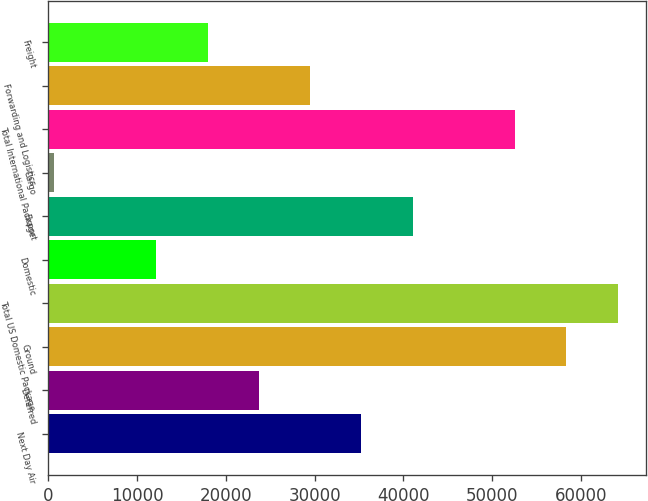Convert chart to OTSL. <chart><loc_0><loc_0><loc_500><loc_500><bar_chart><fcel>Next Day Air<fcel>Deferred<fcel>Ground<fcel>Total US Domestic Package<fcel>Domestic<fcel>Export<fcel>Cargo<fcel>Total International Package<fcel>Forwarding and Logistics<fcel>Freight<nl><fcel>35270.6<fcel>23724.4<fcel>58363<fcel>64136.1<fcel>12178.2<fcel>41043.7<fcel>632<fcel>52589.9<fcel>29497.5<fcel>17951.3<nl></chart> 